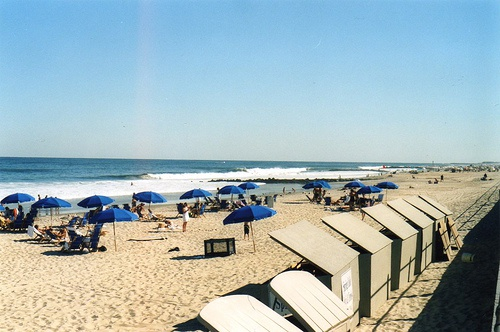Describe the objects in this image and their specific colors. I can see people in lightblue, black, darkgray, gray, and tan tones, umbrella in lightblue, darkgray, and tan tones, umbrella in lightblue, navy, black, blue, and darkblue tones, umbrella in lightblue, navy, and blue tones, and umbrella in lightblue, navy, blue, black, and gray tones in this image. 